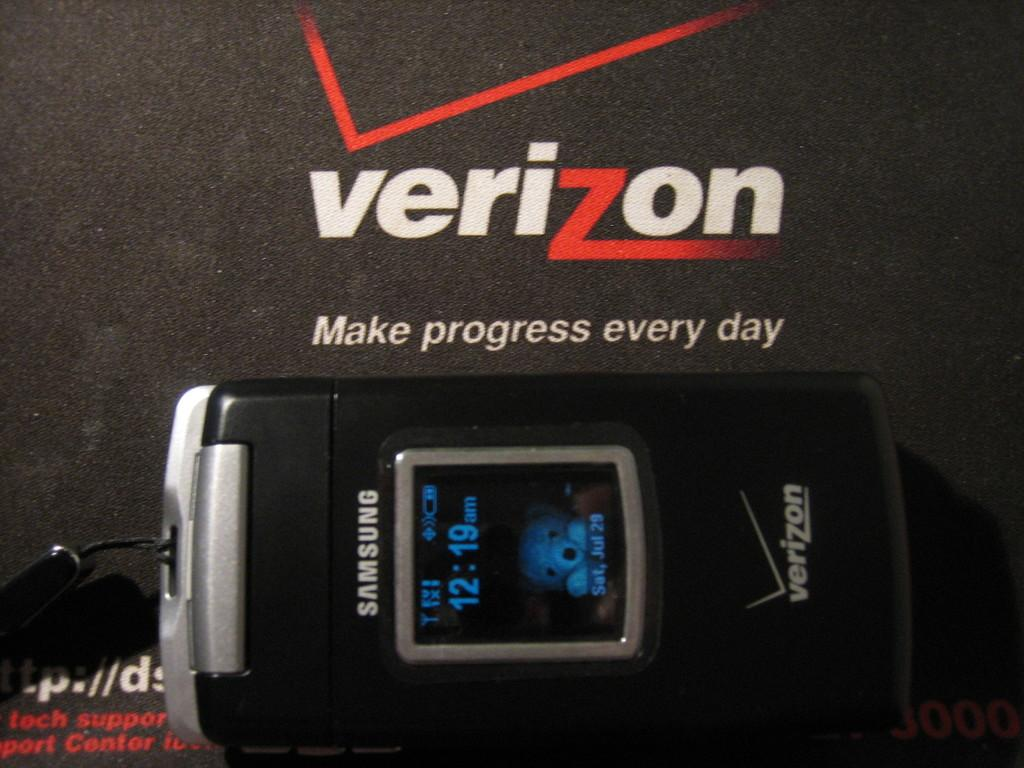<image>
Write a terse but informative summary of the picture. verizon flip phone with external screen showing time at 12:19am 